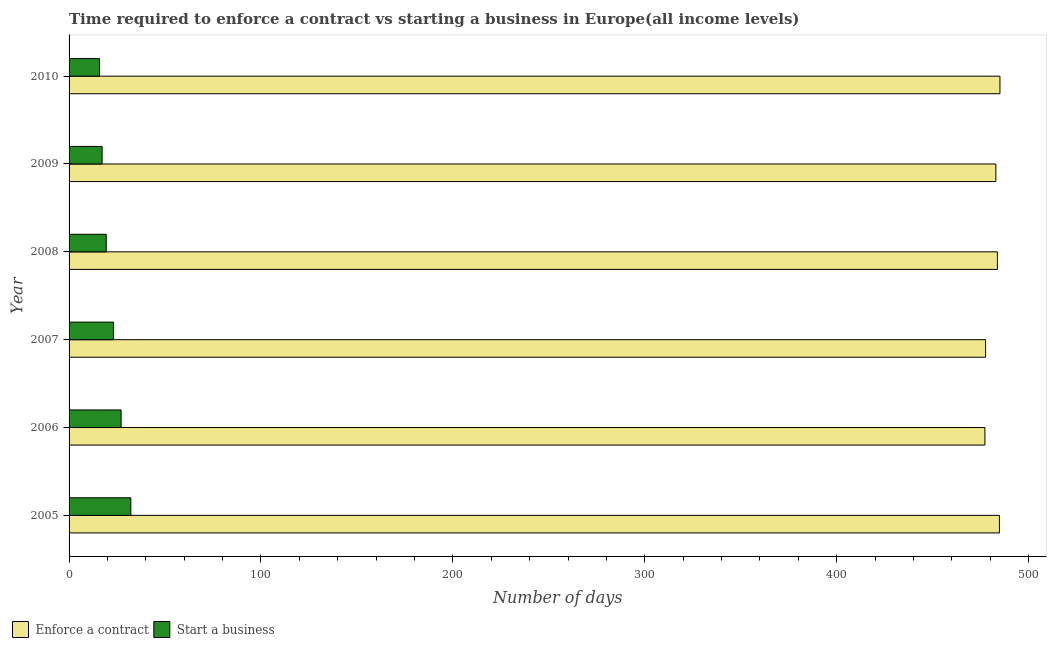How many different coloured bars are there?
Keep it short and to the point. 2. Are the number of bars per tick equal to the number of legend labels?
Offer a very short reply. Yes. Are the number of bars on each tick of the Y-axis equal?
Make the answer very short. Yes. In how many cases, is the number of bars for a given year not equal to the number of legend labels?
Offer a very short reply. 0. What is the number of days to enforece a contract in 2006?
Ensure brevity in your answer.  477.24. Across all years, what is the maximum number of days to enforece a contract?
Provide a succinct answer. 485.09. Across all years, what is the minimum number of days to start a business?
Provide a short and direct response. 15.85. In which year was the number of days to start a business minimum?
Make the answer very short. 2010. What is the total number of days to enforece a contract in the graph?
Offer a terse response. 2891.46. What is the difference between the number of days to start a business in 2006 and that in 2008?
Your answer should be very brief. 7.74. What is the difference between the number of days to start a business in 2010 and the number of days to enforece a contract in 2006?
Give a very brief answer. -461.39. What is the average number of days to start a business per year?
Your answer should be very brief. 22.48. In the year 2007, what is the difference between the number of days to start a business and number of days to enforece a contract?
Provide a succinct answer. -454.47. What is the ratio of the number of days to enforece a contract in 2007 to that in 2009?
Provide a succinct answer. 0.99. Is the number of days to start a business in 2005 less than that in 2006?
Keep it short and to the point. No. Is the difference between the number of days to enforece a contract in 2007 and 2008 greater than the difference between the number of days to start a business in 2007 and 2008?
Make the answer very short. No. What is the difference between the highest and the second highest number of days to start a business?
Ensure brevity in your answer.  5.08. What is the difference between the highest and the lowest number of days to enforece a contract?
Provide a succinct answer. 7.84. In how many years, is the number of days to enforece a contract greater than the average number of days to enforece a contract taken over all years?
Ensure brevity in your answer.  4. What does the 1st bar from the top in 2006 represents?
Keep it short and to the point. Start a business. What does the 1st bar from the bottom in 2010 represents?
Provide a short and direct response. Enforce a contract. How many years are there in the graph?
Offer a terse response. 6. Does the graph contain any zero values?
Offer a very short reply. No. Where does the legend appear in the graph?
Provide a succinct answer. Bottom left. How are the legend labels stacked?
Provide a succinct answer. Horizontal. What is the title of the graph?
Keep it short and to the point. Time required to enforce a contract vs starting a business in Europe(all income levels). Does "Enforce a contract" appear as one of the legend labels in the graph?
Your response must be concise. Yes. What is the label or title of the X-axis?
Offer a very short reply. Number of days. What is the Number of days in Enforce a contract in 2005?
Keep it short and to the point. 484.81. What is the Number of days in Start a business in 2005?
Provide a short and direct response. 32.19. What is the Number of days of Enforce a contract in 2006?
Offer a terse response. 477.24. What is the Number of days of Start a business in 2006?
Offer a terse response. 27.11. What is the Number of days of Enforce a contract in 2007?
Offer a very short reply. 477.6. What is the Number of days of Start a business in 2007?
Offer a terse response. 23.13. What is the Number of days of Enforce a contract in 2008?
Give a very brief answer. 483.76. What is the Number of days of Start a business in 2008?
Ensure brevity in your answer.  19.37. What is the Number of days in Enforce a contract in 2009?
Offer a terse response. 482.96. What is the Number of days in Start a business in 2009?
Offer a terse response. 17.21. What is the Number of days of Enforce a contract in 2010?
Keep it short and to the point. 485.09. What is the Number of days in Start a business in 2010?
Provide a short and direct response. 15.85. Across all years, what is the maximum Number of days of Enforce a contract?
Your answer should be compact. 485.09. Across all years, what is the maximum Number of days in Start a business?
Offer a very short reply. 32.19. Across all years, what is the minimum Number of days in Enforce a contract?
Provide a short and direct response. 477.24. Across all years, what is the minimum Number of days of Start a business?
Make the answer very short. 15.85. What is the total Number of days of Enforce a contract in the graph?
Make the answer very short. 2891.46. What is the total Number of days in Start a business in the graph?
Provide a succinct answer. 134.86. What is the difference between the Number of days in Enforce a contract in 2005 and that in 2006?
Keep it short and to the point. 7.57. What is the difference between the Number of days of Start a business in 2005 and that in 2006?
Ensure brevity in your answer.  5.07. What is the difference between the Number of days in Enforce a contract in 2005 and that in 2007?
Offer a terse response. 7.21. What is the difference between the Number of days in Start a business in 2005 and that in 2007?
Your response must be concise. 9.05. What is the difference between the Number of days of Enforce a contract in 2005 and that in 2008?
Your response must be concise. 1.05. What is the difference between the Number of days of Start a business in 2005 and that in 2008?
Give a very brief answer. 12.82. What is the difference between the Number of days of Enforce a contract in 2005 and that in 2009?
Your answer should be compact. 1.86. What is the difference between the Number of days in Start a business in 2005 and that in 2009?
Give a very brief answer. 14.97. What is the difference between the Number of days of Enforce a contract in 2005 and that in 2010?
Ensure brevity in your answer.  -0.27. What is the difference between the Number of days in Start a business in 2005 and that in 2010?
Provide a short and direct response. 16.34. What is the difference between the Number of days of Enforce a contract in 2006 and that in 2007?
Provide a succinct answer. -0.36. What is the difference between the Number of days in Start a business in 2006 and that in 2007?
Offer a terse response. 3.98. What is the difference between the Number of days in Enforce a contract in 2006 and that in 2008?
Your answer should be compact. -6.52. What is the difference between the Number of days of Start a business in 2006 and that in 2008?
Provide a short and direct response. 7.74. What is the difference between the Number of days in Enforce a contract in 2006 and that in 2009?
Your answer should be very brief. -5.71. What is the difference between the Number of days in Start a business in 2006 and that in 2009?
Keep it short and to the point. 9.9. What is the difference between the Number of days in Enforce a contract in 2006 and that in 2010?
Make the answer very short. -7.84. What is the difference between the Number of days of Start a business in 2006 and that in 2010?
Provide a succinct answer. 11.26. What is the difference between the Number of days of Enforce a contract in 2007 and that in 2008?
Make the answer very short. -6.16. What is the difference between the Number of days in Start a business in 2007 and that in 2008?
Provide a succinct answer. 3.76. What is the difference between the Number of days in Enforce a contract in 2007 and that in 2009?
Your answer should be very brief. -5.36. What is the difference between the Number of days of Start a business in 2007 and that in 2009?
Make the answer very short. 5.92. What is the difference between the Number of days in Enforce a contract in 2007 and that in 2010?
Your response must be concise. -7.49. What is the difference between the Number of days of Start a business in 2007 and that in 2010?
Offer a terse response. 7.28. What is the difference between the Number of days in Enforce a contract in 2008 and that in 2009?
Provide a short and direct response. 0.8. What is the difference between the Number of days in Start a business in 2008 and that in 2009?
Make the answer very short. 2.16. What is the difference between the Number of days of Enforce a contract in 2008 and that in 2010?
Ensure brevity in your answer.  -1.32. What is the difference between the Number of days in Start a business in 2008 and that in 2010?
Provide a succinct answer. 3.52. What is the difference between the Number of days in Enforce a contract in 2009 and that in 2010?
Offer a terse response. -2.13. What is the difference between the Number of days in Start a business in 2009 and that in 2010?
Provide a succinct answer. 1.36. What is the difference between the Number of days in Enforce a contract in 2005 and the Number of days in Start a business in 2006?
Make the answer very short. 457.7. What is the difference between the Number of days in Enforce a contract in 2005 and the Number of days in Start a business in 2007?
Provide a succinct answer. 461.68. What is the difference between the Number of days of Enforce a contract in 2005 and the Number of days of Start a business in 2008?
Offer a terse response. 465.44. What is the difference between the Number of days of Enforce a contract in 2005 and the Number of days of Start a business in 2009?
Keep it short and to the point. 467.6. What is the difference between the Number of days in Enforce a contract in 2005 and the Number of days in Start a business in 2010?
Ensure brevity in your answer.  468.96. What is the difference between the Number of days in Enforce a contract in 2006 and the Number of days in Start a business in 2007?
Offer a terse response. 454.11. What is the difference between the Number of days of Enforce a contract in 2006 and the Number of days of Start a business in 2008?
Ensure brevity in your answer.  457.87. What is the difference between the Number of days in Enforce a contract in 2006 and the Number of days in Start a business in 2009?
Make the answer very short. 460.03. What is the difference between the Number of days in Enforce a contract in 2006 and the Number of days in Start a business in 2010?
Keep it short and to the point. 461.39. What is the difference between the Number of days in Enforce a contract in 2007 and the Number of days in Start a business in 2008?
Ensure brevity in your answer.  458.23. What is the difference between the Number of days in Enforce a contract in 2007 and the Number of days in Start a business in 2009?
Provide a short and direct response. 460.39. What is the difference between the Number of days of Enforce a contract in 2007 and the Number of days of Start a business in 2010?
Keep it short and to the point. 461.75. What is the difference between the Number of days in Enforce a contract in 2008 and the Number of days in Start a business in 2009?
Your response must be concise. 466.55. What is the difference between the Number of days in Enforce a contract in 2008 and the Number of days in Start a business in 2010?
Provide a short and direct response. 467.91. What is the difference between the Number of days of Enforce a contract in 2009 and the Number of days of Start a business in 2010?
Ensure brevity in your answer.  467.11. What is the average Number of days in Enforce a contract per year?
Provide a succinct answer. 481.91. What is the average Number of days in Start a business per year?
Give a very brief answer. 22.48. In the year 2005, what is the difference between the Number of days in Enforce a contract and Number of days in Start a business?
Offer a terse response. 452.63. In the year 2006, what is the difference between the Number of days of Enforce a contract and Number of days of Start a business?
Ensure brevity in your answer.  450.13. In the year 2007, what is the difference between the Number of days of Enforce a contract and Number of days of Start a business?
Your answer should be compact. 454.47. In the year 2008, what is the difference between the Number of days of Enforce a contract and Number of days of Start a business?
Ensure brevity in your answer.  464.39. In the year 2009, what is the difference between the Number of days of Enforce a contract and Number of days of Start a business?
Ensure brevity in your answer.  465.74. In the year 2010, what is the difference between the Number of days in Enforce a contract and Number of days in Start a business?
Provide a succinct answer. 469.23. What is the ratio of the Number of days of Enforce a contract in 2005 to that in 2006?
Provide a succinct answer. 1.02. What is the ratio of the Number of days in Start a business in 2005 to that in 2006?
Give a very brief answer. 1.19. What is the ratio of the Number of days of Enforce a contract in 2005 to that in 2007?
Keep it short and to the point. 1.02. What is the ratio of the Number of days in Start a business in 2005 to that in 2007?
Provide a succinct answer. 1.39. What is the ratio of the Number of days in Enforce a contract in 2005 to that in 2008?
Your answer should be compact. 1. What is the ratio of the Number of days in Start a business in 2005 to that in 2008?
Provide a succinct answer. 1.66. What is the ratio of the Number of days in Enforce a contract in 2005 to that in 2009?
Your answer should be compact. 1. What is the ratio of the Number of days of Start a business in 2005 to that in 2009?
Your response must be concise. 1.87. What is the ratio of the Number of days of Enforce a contract in 2005 to that in 2010?
Keep it short and to the point. 1. What is the ratio of the Number of days of Start a business in 2005 to that in 2010?
Your answer should be compact. 2.03. What is the ratio of the Number of days of Start a business in 2006 to that in 2007?
Offer a very short reply. 1.17. What is the ratio of the Number of days of Enforce a contract in 2006 to that in 2008?
Ensure brevity in your answer.  0.99. What is the ratio of the Number of days in Start a business in 2006 to that in 2008?
Offer a terse response. 1.4. What is the ratio of the Number of days in Enforce a contract in 2006 to that in 2009?
Provide a succinct answer. 0.99. What is the ratio of the Number of days of Start a business in 2006 to that in 2009?
Ensure brevity in your answer.  1.58. What is the ratio of the Number of days in Enforce a contract in 2006 to that in 2010?
Provide a succinct answer. 0.98. What is the ratio of the Number of days of Start a business in 2006 to that in 2010?
Make the answer very short. 1.71. What is the ratio of the Number of days of Enforce a contract in 2007 to that in 2008?
Keep it short and to the point. 0.99. What is the ratio of the Number of days in Start a business in 2007 to that in 2008?
Your response must be concise. 1.19. What is the ratio of the Number of days of Enforce a contract in 2007 to that in 2009?
Your answer should be compact. 0.99. What is the ratio of the Number of days in Start a business in 2007 to that in 2009?
Your answer should be very brief. 1.34. What is the ratio of the Number of days in Enforce a contract in 2007 to that in 2010?
Ensure brevity in your answer.  0.98. What is the ratio of the Number of days of Start a business in 2007 to that in 2010?
Your answer should be very brief. 1.46. What is the ratio of the Number of days in Start a business in 2008 to that in 2009?
Your answer should be compact. 1.13. What is the ratio of the Number of days of Start a business in 2008 to that in 2010?
Keep it short and to the point. 1.22. What is the ratio of the Number of days in Start a business in 2009 to that in 2010?
Offer a terse response. 1.09. What is the difference between the highest and the second highest Number of days in Enforce a contract?
Make the answer very short. 0.27. What is the difference between the highest and the second highest Number of days in Start a business?
Offer a terse response. 5.07. What is the difference between the highest and the lowest Number of days in Enforce a contract?
Your answer should be compact. 7.84. What is the difference between the highest and the lowest Number of days of Start a business?
Your answer should be compact. 16.34. 